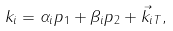Convert formula to latex. <formula><loc_0><loc_0><loc_500><loc_500>k _ { i } = \alpha _ { i } p _ { 1 } + \beta _ { i } p _ { 2 } + \vec { k } _ { i T } ,</formula> 